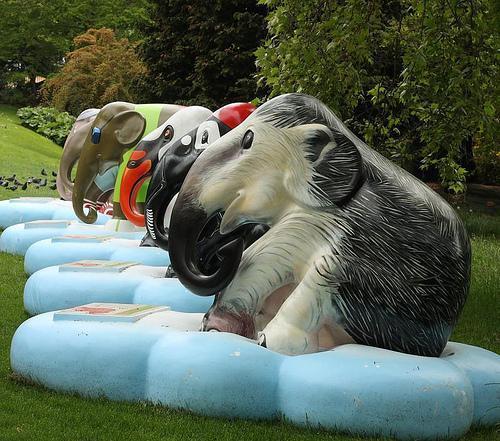How many statues are there?
Give a very brief answer. 5. 